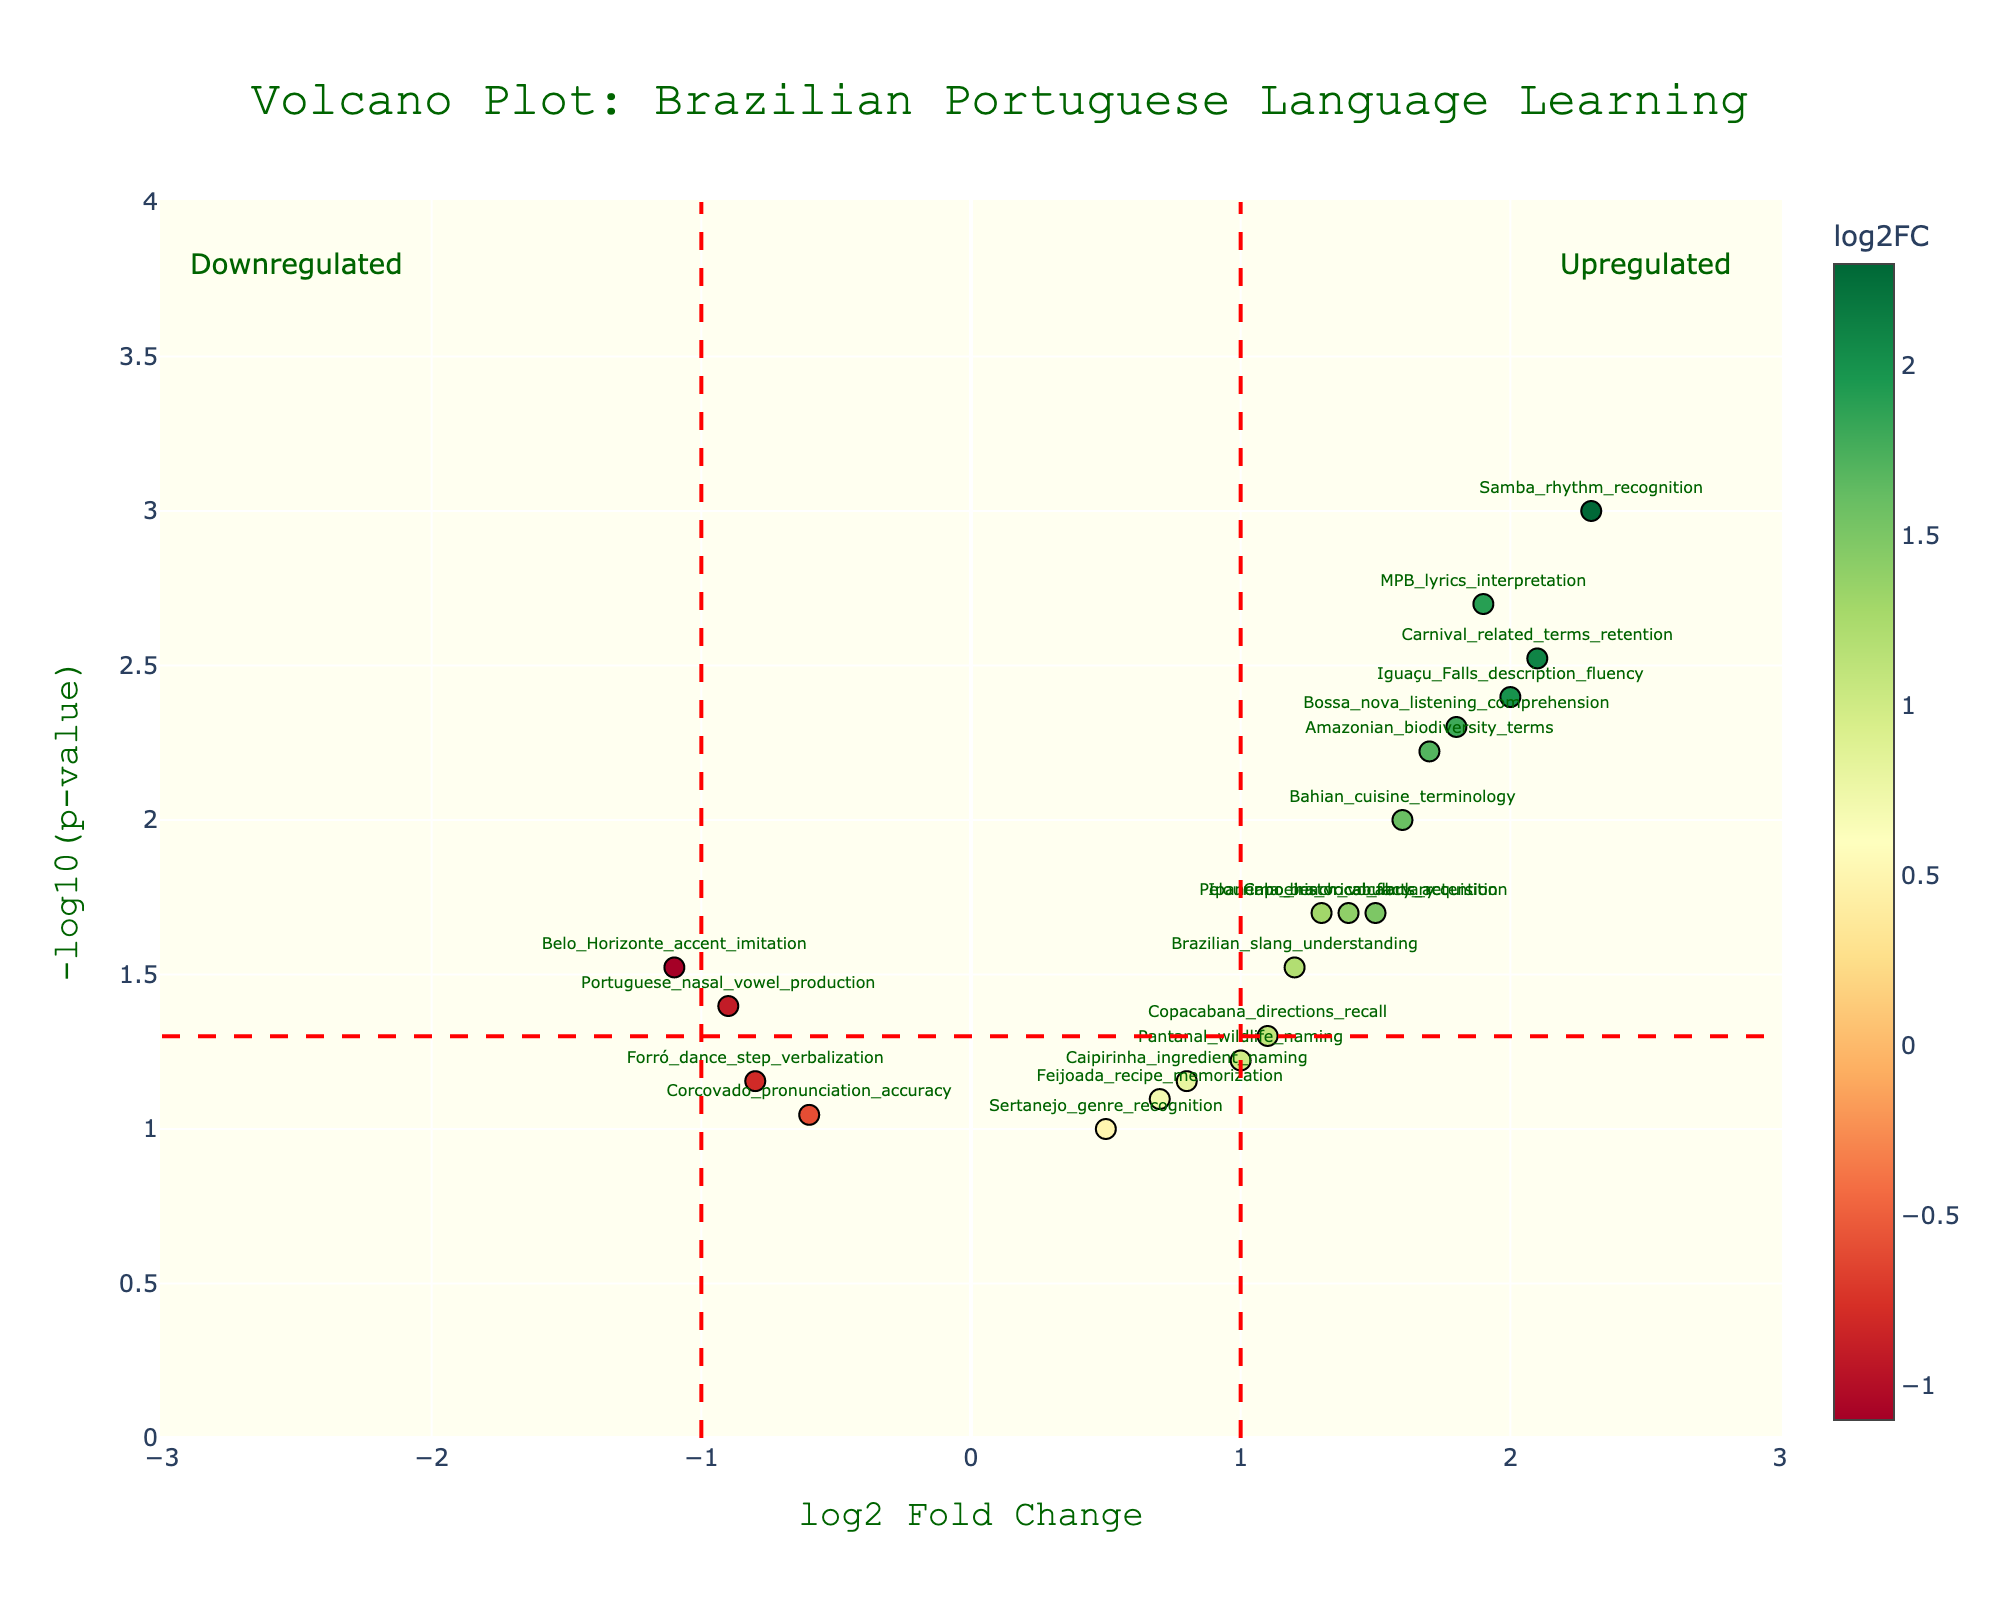What is the title of the plot? The title of the plot is usually located at the top and is clearly labeled to describe the main subject of the figure. Here, it reads "Volcano Plot: Brazilian Portuguese Language Learning".
Answer: Volcano Plot: Brazilian Portuguese Language Learning How many genes have a log2 Fold Change (log2FC) greater than 2? To determine this, count the points to the right of 2 on the x-axis; Samba_rhythm_recognition, Carnival_related_terms_retention, and Iguaçu_Falls_description_fluency have log2FC values greater than 2.
Answer: 3 Which gene has the highest -log10(p-value)? The highest -log10(p-value) appears at the top of the y-axis. According to the figure, Samba_rhythm_recognition has the highest -log10(p-value).
Answer: Samba_rhythm_recognition Are there any genes with a negative log2 Fold Change? If so, which ones? Look to the left side of the x-axis for negative log2 Fold Change values. The genes with negative log2 Fold Change are: Portuguese_nasal_vowel_production, Belo_Horizonte_accent_imitation, Forró_dance_step_verbalization, and Corcovado_pronunciation_accuracy.
Answer: Portuguese_nasal_vowel_production, Belo_Horizonte_accent_imitation, Forró_dance_step_verbalization, Corcovado_pronunciation_accuracy Which gene related to cultural vocabulary has the lowest p-value? Find the gene with cultural vocabulary terminology that has the smallest p-value (or highest -log10(p-value)). MPB_lyrics_interpretation stands out as it is related to cultural vocabulary and has a high -log10(p-value), indicating a low p-value.
Answer: MPB_lyrics_interpretation What is the log2 Fold Change and p-value for Bossa_nova_listening_comprehension? Hover over or locate the marker for Bossa_nova_listening_comprehension to read its log2 Fold Change (1.8) and p-value (0.005).
Answer: log2FC: 1.8, p-value: 0.005 Compare the log2 Fold Change values for Ipanema_beach_vocabulary and Amazonian_biodiversity_terms. Which one is higher? Locate and compare the positions on the x-axis for both genes. Ipanema_beach_vocabulary has a log2FC of 1.3, while Amazonian_biodiversity_terms has a log2FC of 1.7.
Answer: Amazonian_biodiversity_terms What is the general trend for the points labeled as upregulated? Upregulated points are typically to the right of the x-axis line where the log2 Fold Change is positive. These points tend to have higher log2 Fold Change and generally lower p-values (higher -log10(pvalue)).
Answer: Higher log2 Fold Change, lower p-values How many genes have a p-value lower than 0.01? Identify the points above the horizontal dashed line at -log10(p-value) = 2 in the plot, which represents a p-value of 0.01. The genes are Samba_rhythm_recognition, MPB_lyrics_interpretation, Carnival_related_terms_retention, Iguaçu_Falls_description_fluency, Bahian_cuisine_terminology, and Amazonian_biodiversity_terms.
Answer: 6 